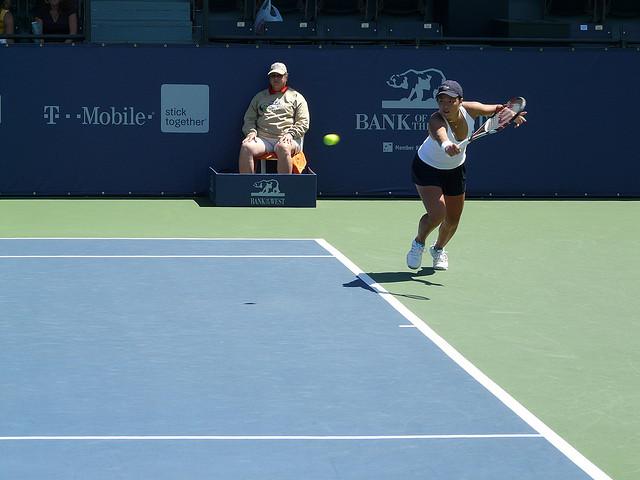What is the name of the bank?
Quick response, please. Bank of west. Is the player in the center court?
Concise answer only. No. Is he sitting still?
Give a very brief answer. Yes. What sport is being played?
Write a very short answer. Tennis. What color is the girl's shirt?
Write a very short answer. White. How many people are in the picture?
Give a very brief answer. 2. What clothing label is a sponsor of this event?
Short answer required. None. 